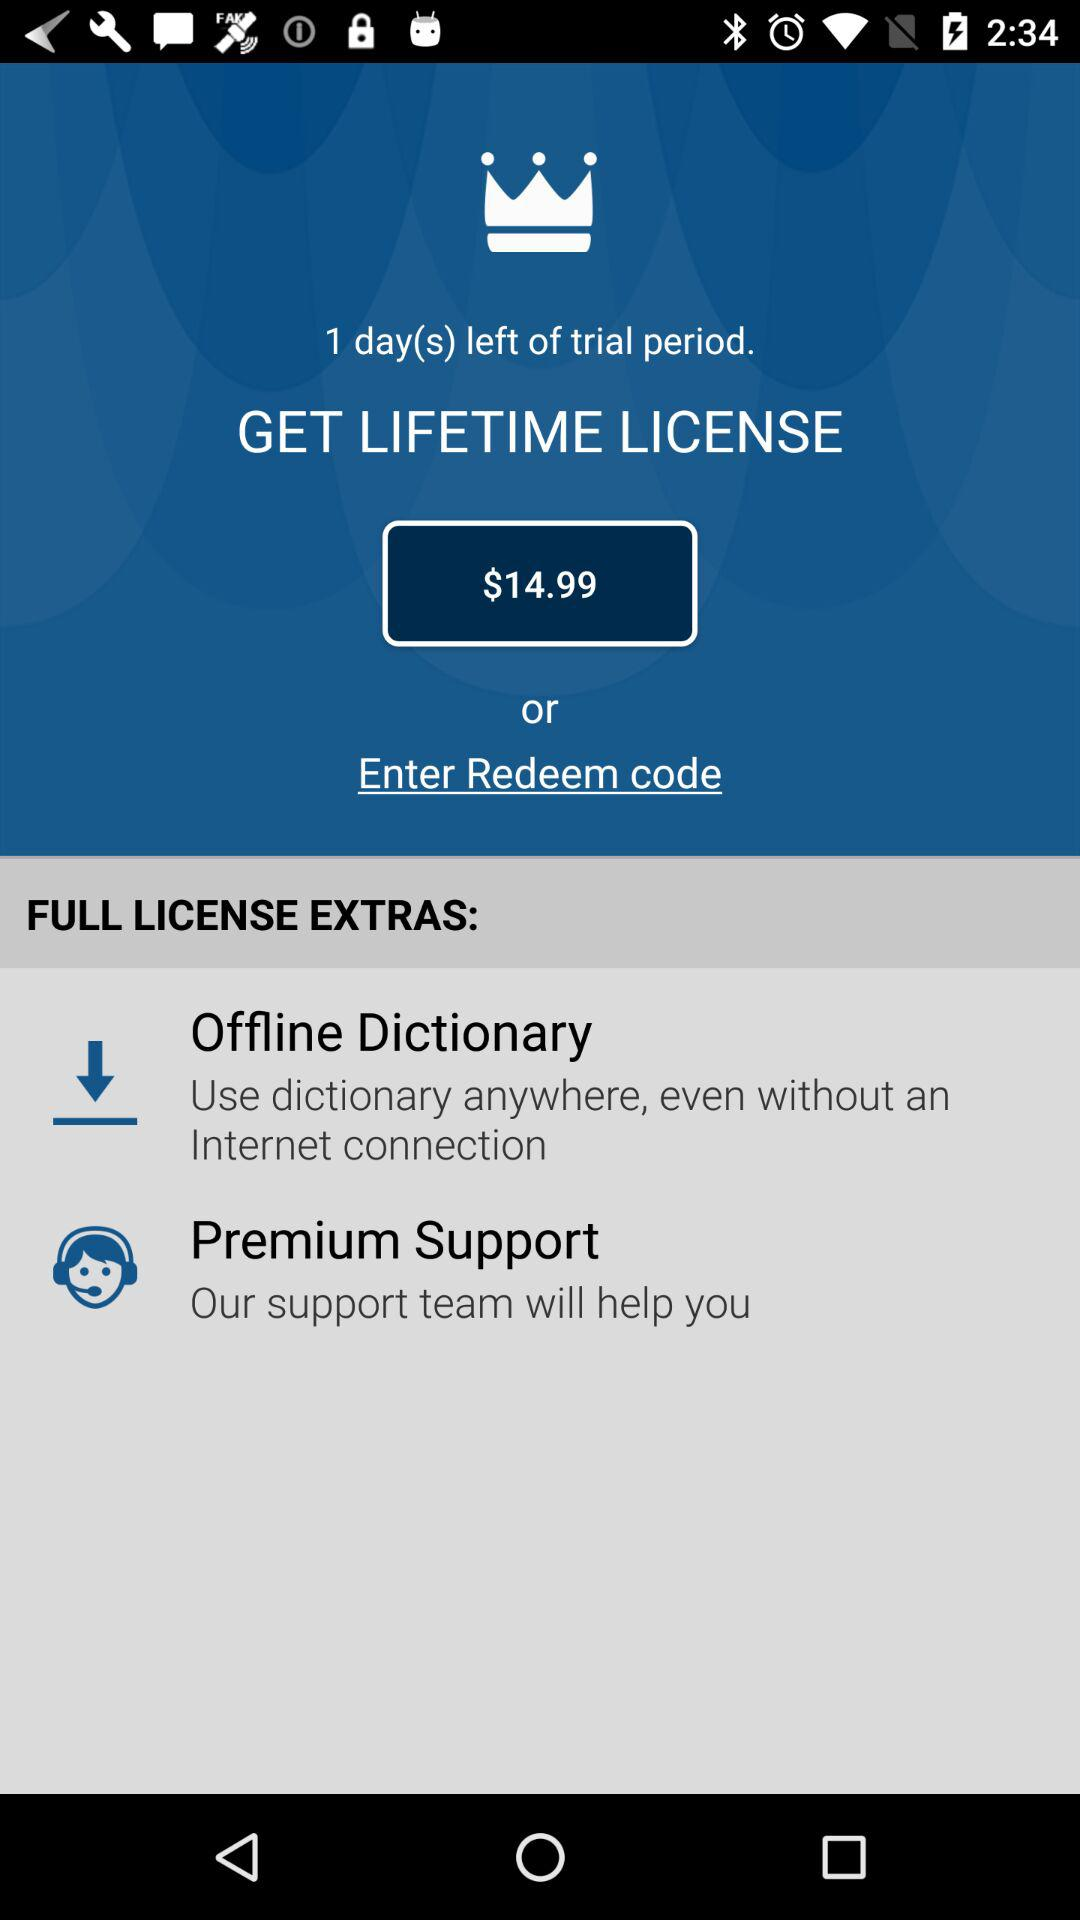What is the price of a lifetime license? The price of a lifetime license is $14.99. 